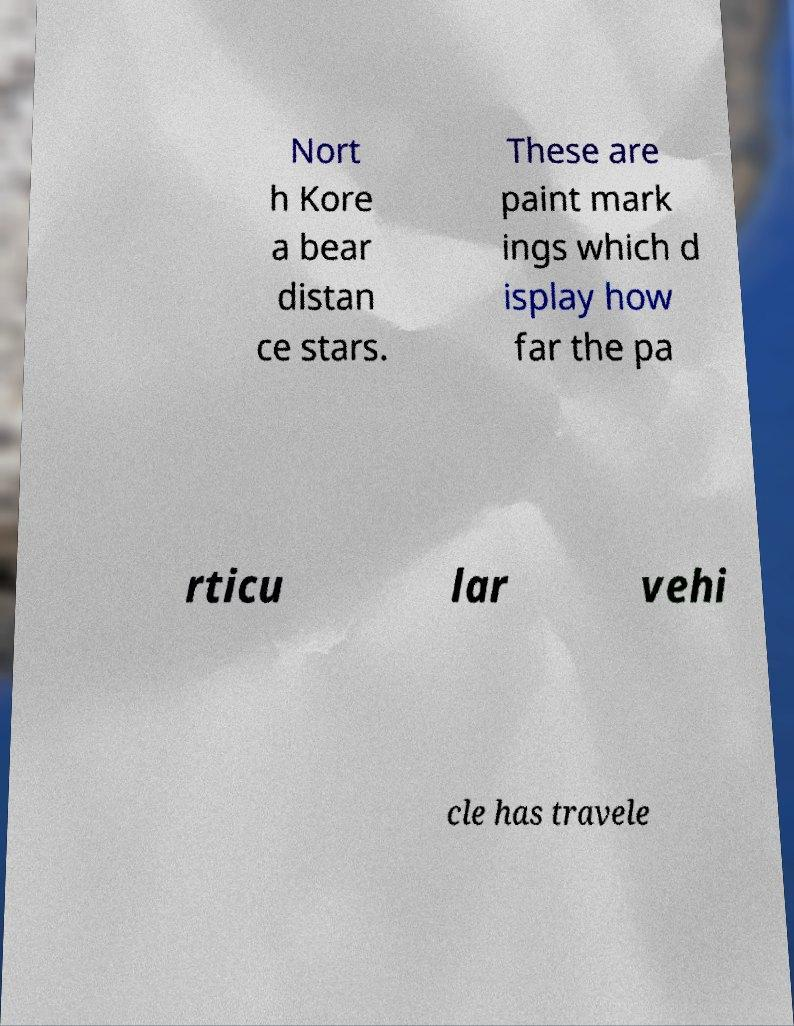Can you accurately transcribe the text from the provided image for me? Nort h Kore a bear distan ce stars. These are paint mark ings which d isplay how far the pa rticu lar vehi cle has travele 